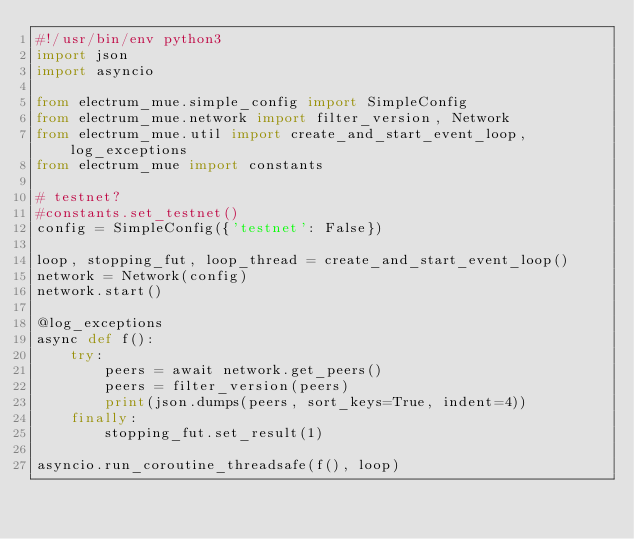Convert code to text. <code><loc_0><loc_0><loc_500><loc_500><_Python_>#!/usr/bin/env python3
import json
import asyncio

from electrum_mue.simple_config import SimpleConfig
from electrum_mue.network import filter_version, Network
from electrum_mue.util import create_and_start_event_loop, log_exceptions
from electrum_mue import constants

# testnet?
#constants.set_testnet()
config = SimpleConfig({'testnet': False})

loop, stopping_fut, loop_thread = create_and_start_event_loop()
network = Network(config)
network.start()

@log_exceptions
async def f():
    try:
        peers = await network.get_peers()
        peers = filter_version(peers)
        print(json.dumps(peers, sort_keys=True, indent=4))
    finally:
        stopping_fut.set_result(1)

asyncio.run_coroutine_threadsafe(f(), loop)
</code> 